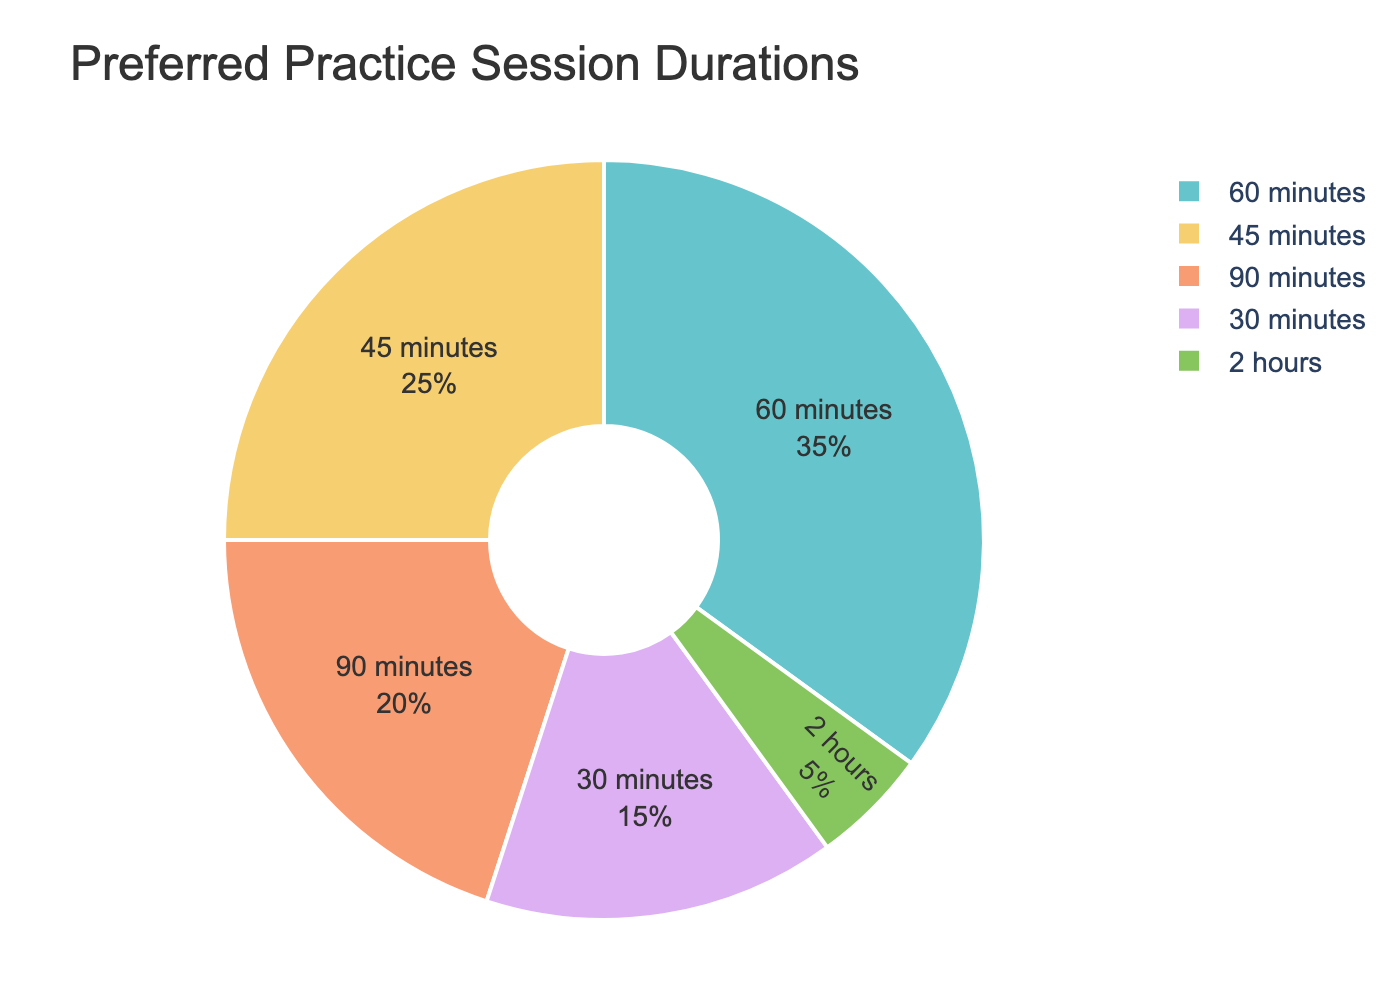What's the most preferred practice session duration? The pie chart shows that the largest segment represents the 60 minutes duration. This segment occupies 35% of the pie chart, which is the highest percentage among all the segments.
Answer: 60 minutes What's the total percentage of group members preferring sessions of 45 minutes or shorter? Add the percentages of the 30 minutes and 45 minutes segments. 15% (30 minutes) + 25% (45 minutes) = 40%.
Answer: 40% Which practice session duration has the least preference among group members? The smallest segment in the pie chart represents the 2 hours duration, which occupies 5%. This is the lowest percentage among all the segments.
Answer: 2 hours Is the percentage of members preferring 90-minute sessions greater than those preferring 45-minute sessions? The pie chart shows the percentages of 90 minutes and 45 minutes as 20% and 25%, respectively. 20% is less than 25%, so the answer is no.
Answer: No What's the combined percentage preference for sessions lasting 60 minutes or longer? Combine the percentages of 60 minutes (35%), 90 minutes (20%), and 2 hours (5%). 35% + 20% + 5% = 60%.
Answer: 60% How many more percentage points prefer 60-minute sessions compared to 30-minute sessions? The percentage for 60 minutes is 35%, and for 30 minutes, it is 15%. Subtract the smaller percentage from the larger one: 35% - 15% = 20%.
Answer: 20% Which two practice session durations, when combined, form half of the group's preferences? We need to find two segments that add up to 50%. The two segments with 30 and 45 minutes have percentages of 15% and 25% respectively. 15% + 25% = 40%. Similarly, the 45 minutes (25%) and 90 minutes (20%) sum up to 45%. None of these add up to 50%. The 60 minutes (35%) and 15% (30 minutes) sum to 50%.
Answer: 30 minutes and 60 minutes Which color represents the duration with the second most preference? The second largest segment represents the 45 minutes duration, which occupies 25% of the pie chart. The segment color is dependent on the color scheme in the rendered figure, so this will need to be verified visually.
Answer: (Color depends on the rendered figure) What is the difference in preference between the most and least preferred durations? The most preferred duration (60 minutes) has a percentage of 35%, and the least preferred (2 hours) has a percentage of 5%. The difference is 35% - 5% = 30%.
Answer: 30% Is the preference for 45-minute sessions more than twice that of 2-hour sessions? The percentage preference for 45 minutes is 25%, and for 2-hour sessions is 5%. Twice the 2-hour percentage is 2 * 5% = 10%. 25% is indeed more than twice 10%.
Answer: Yes 